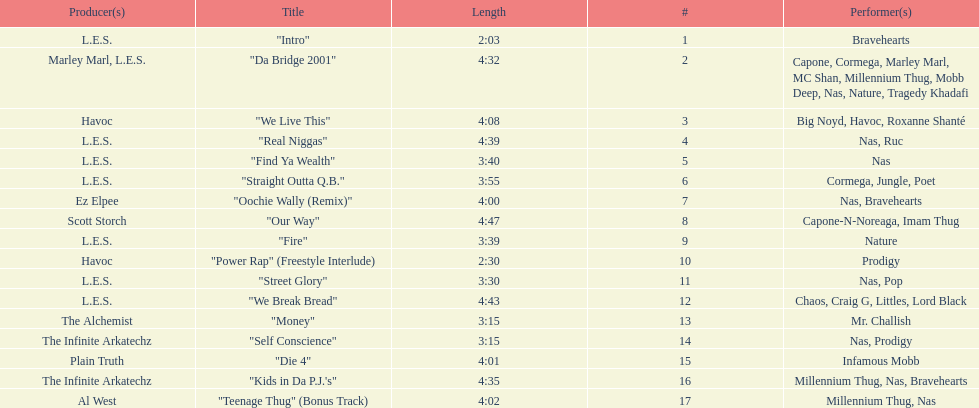Which is more extended, fire or die 4? "Die 4". 